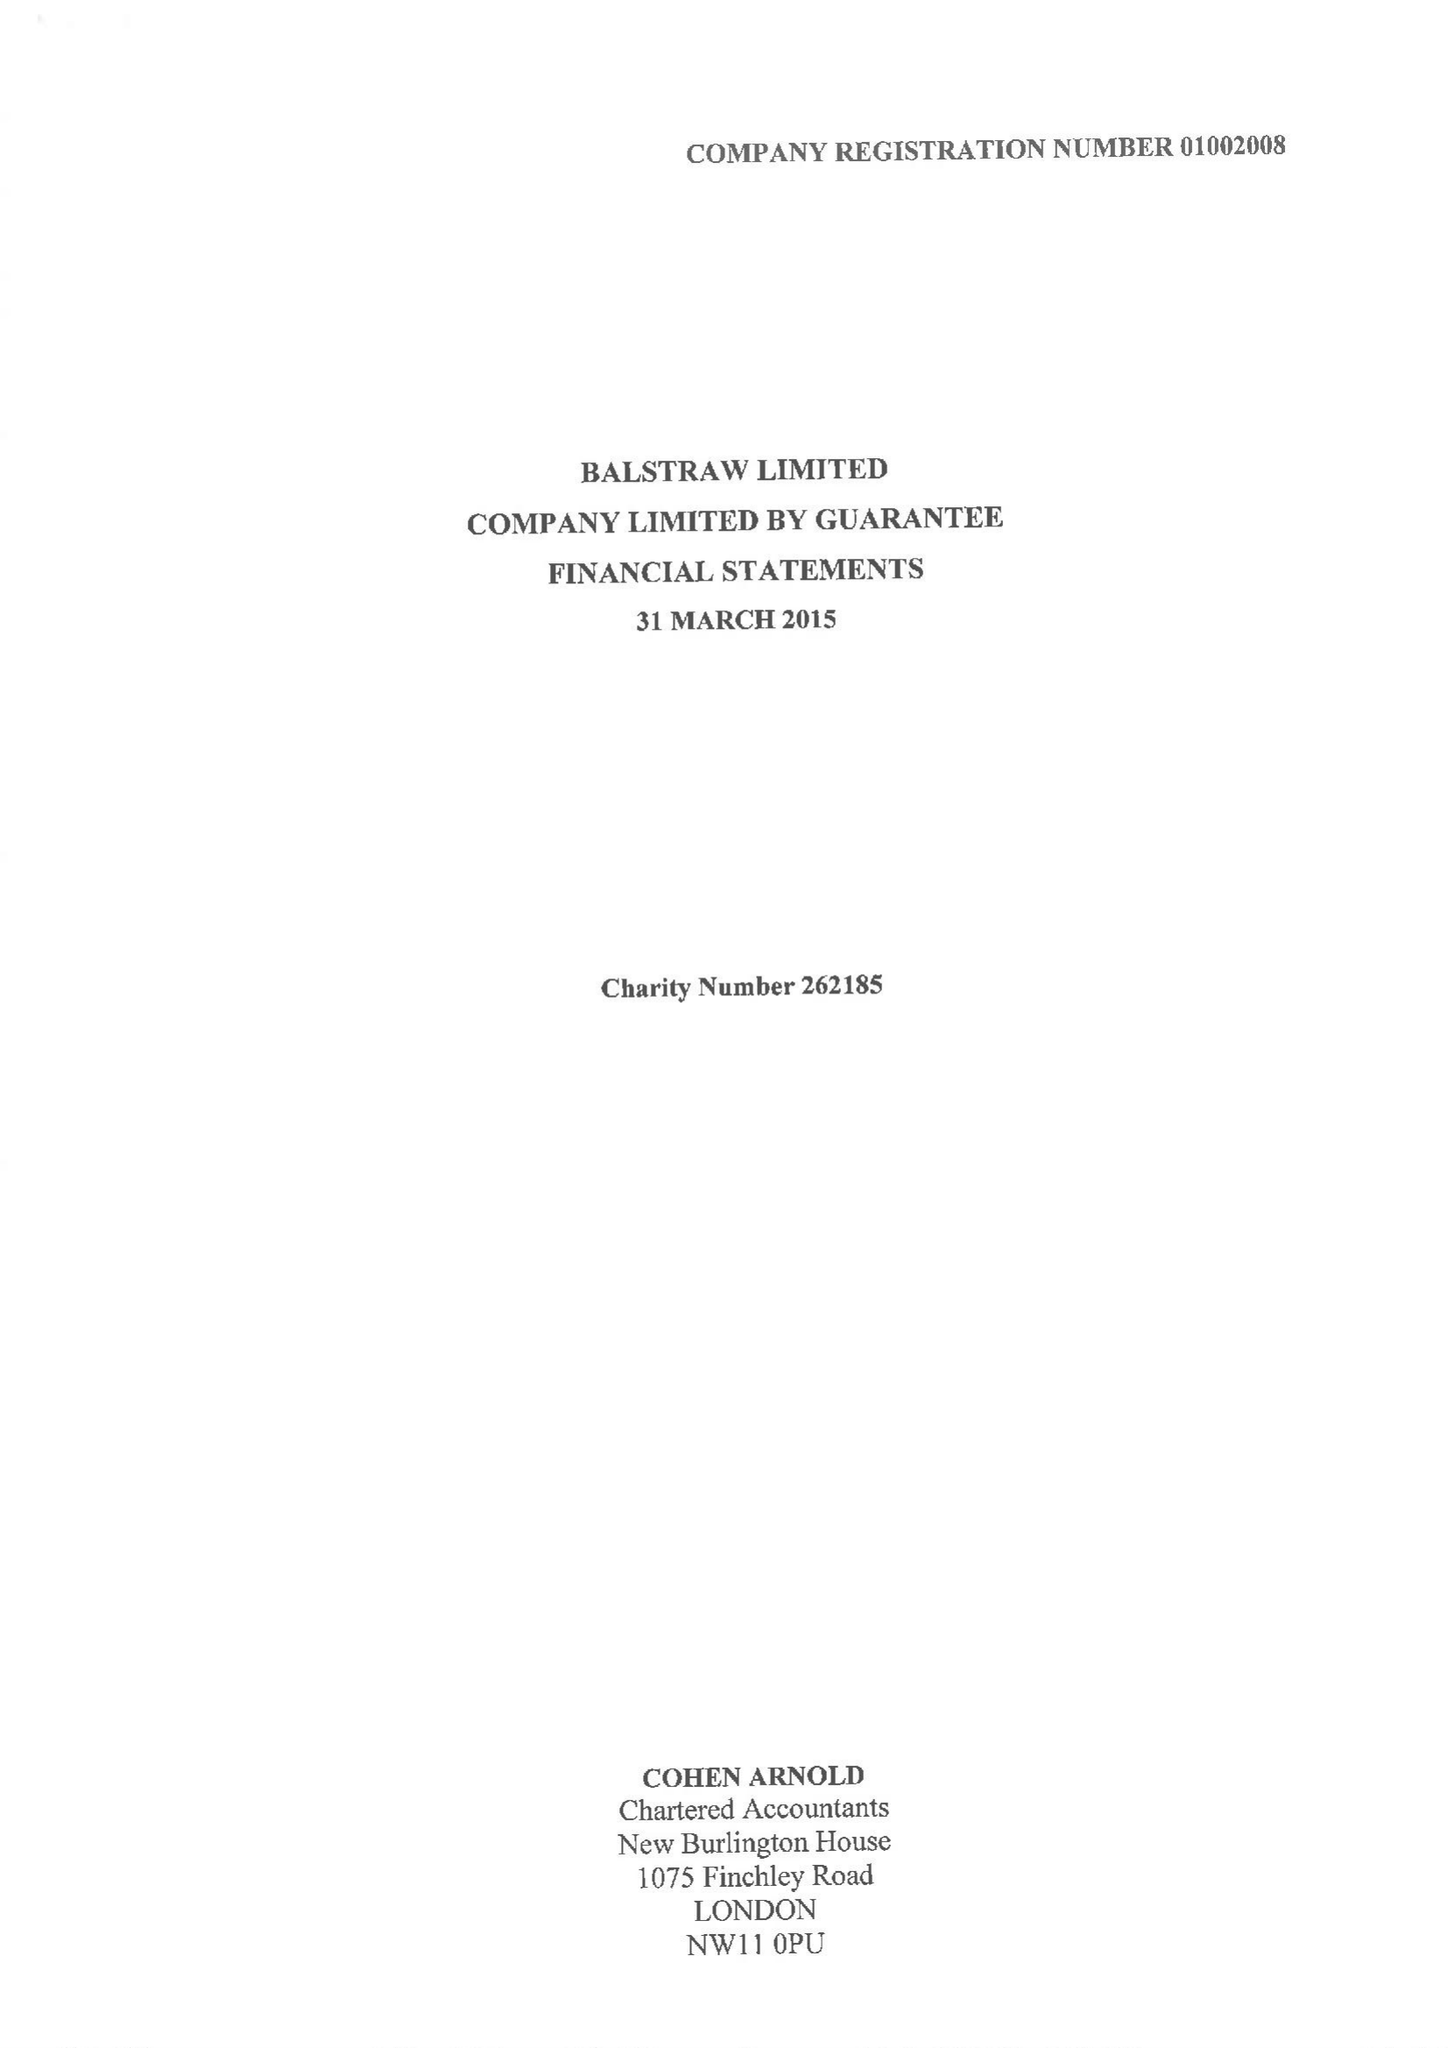What is the value for the report_date?
Answer the question using a single word or phrase. 2015-03-31 